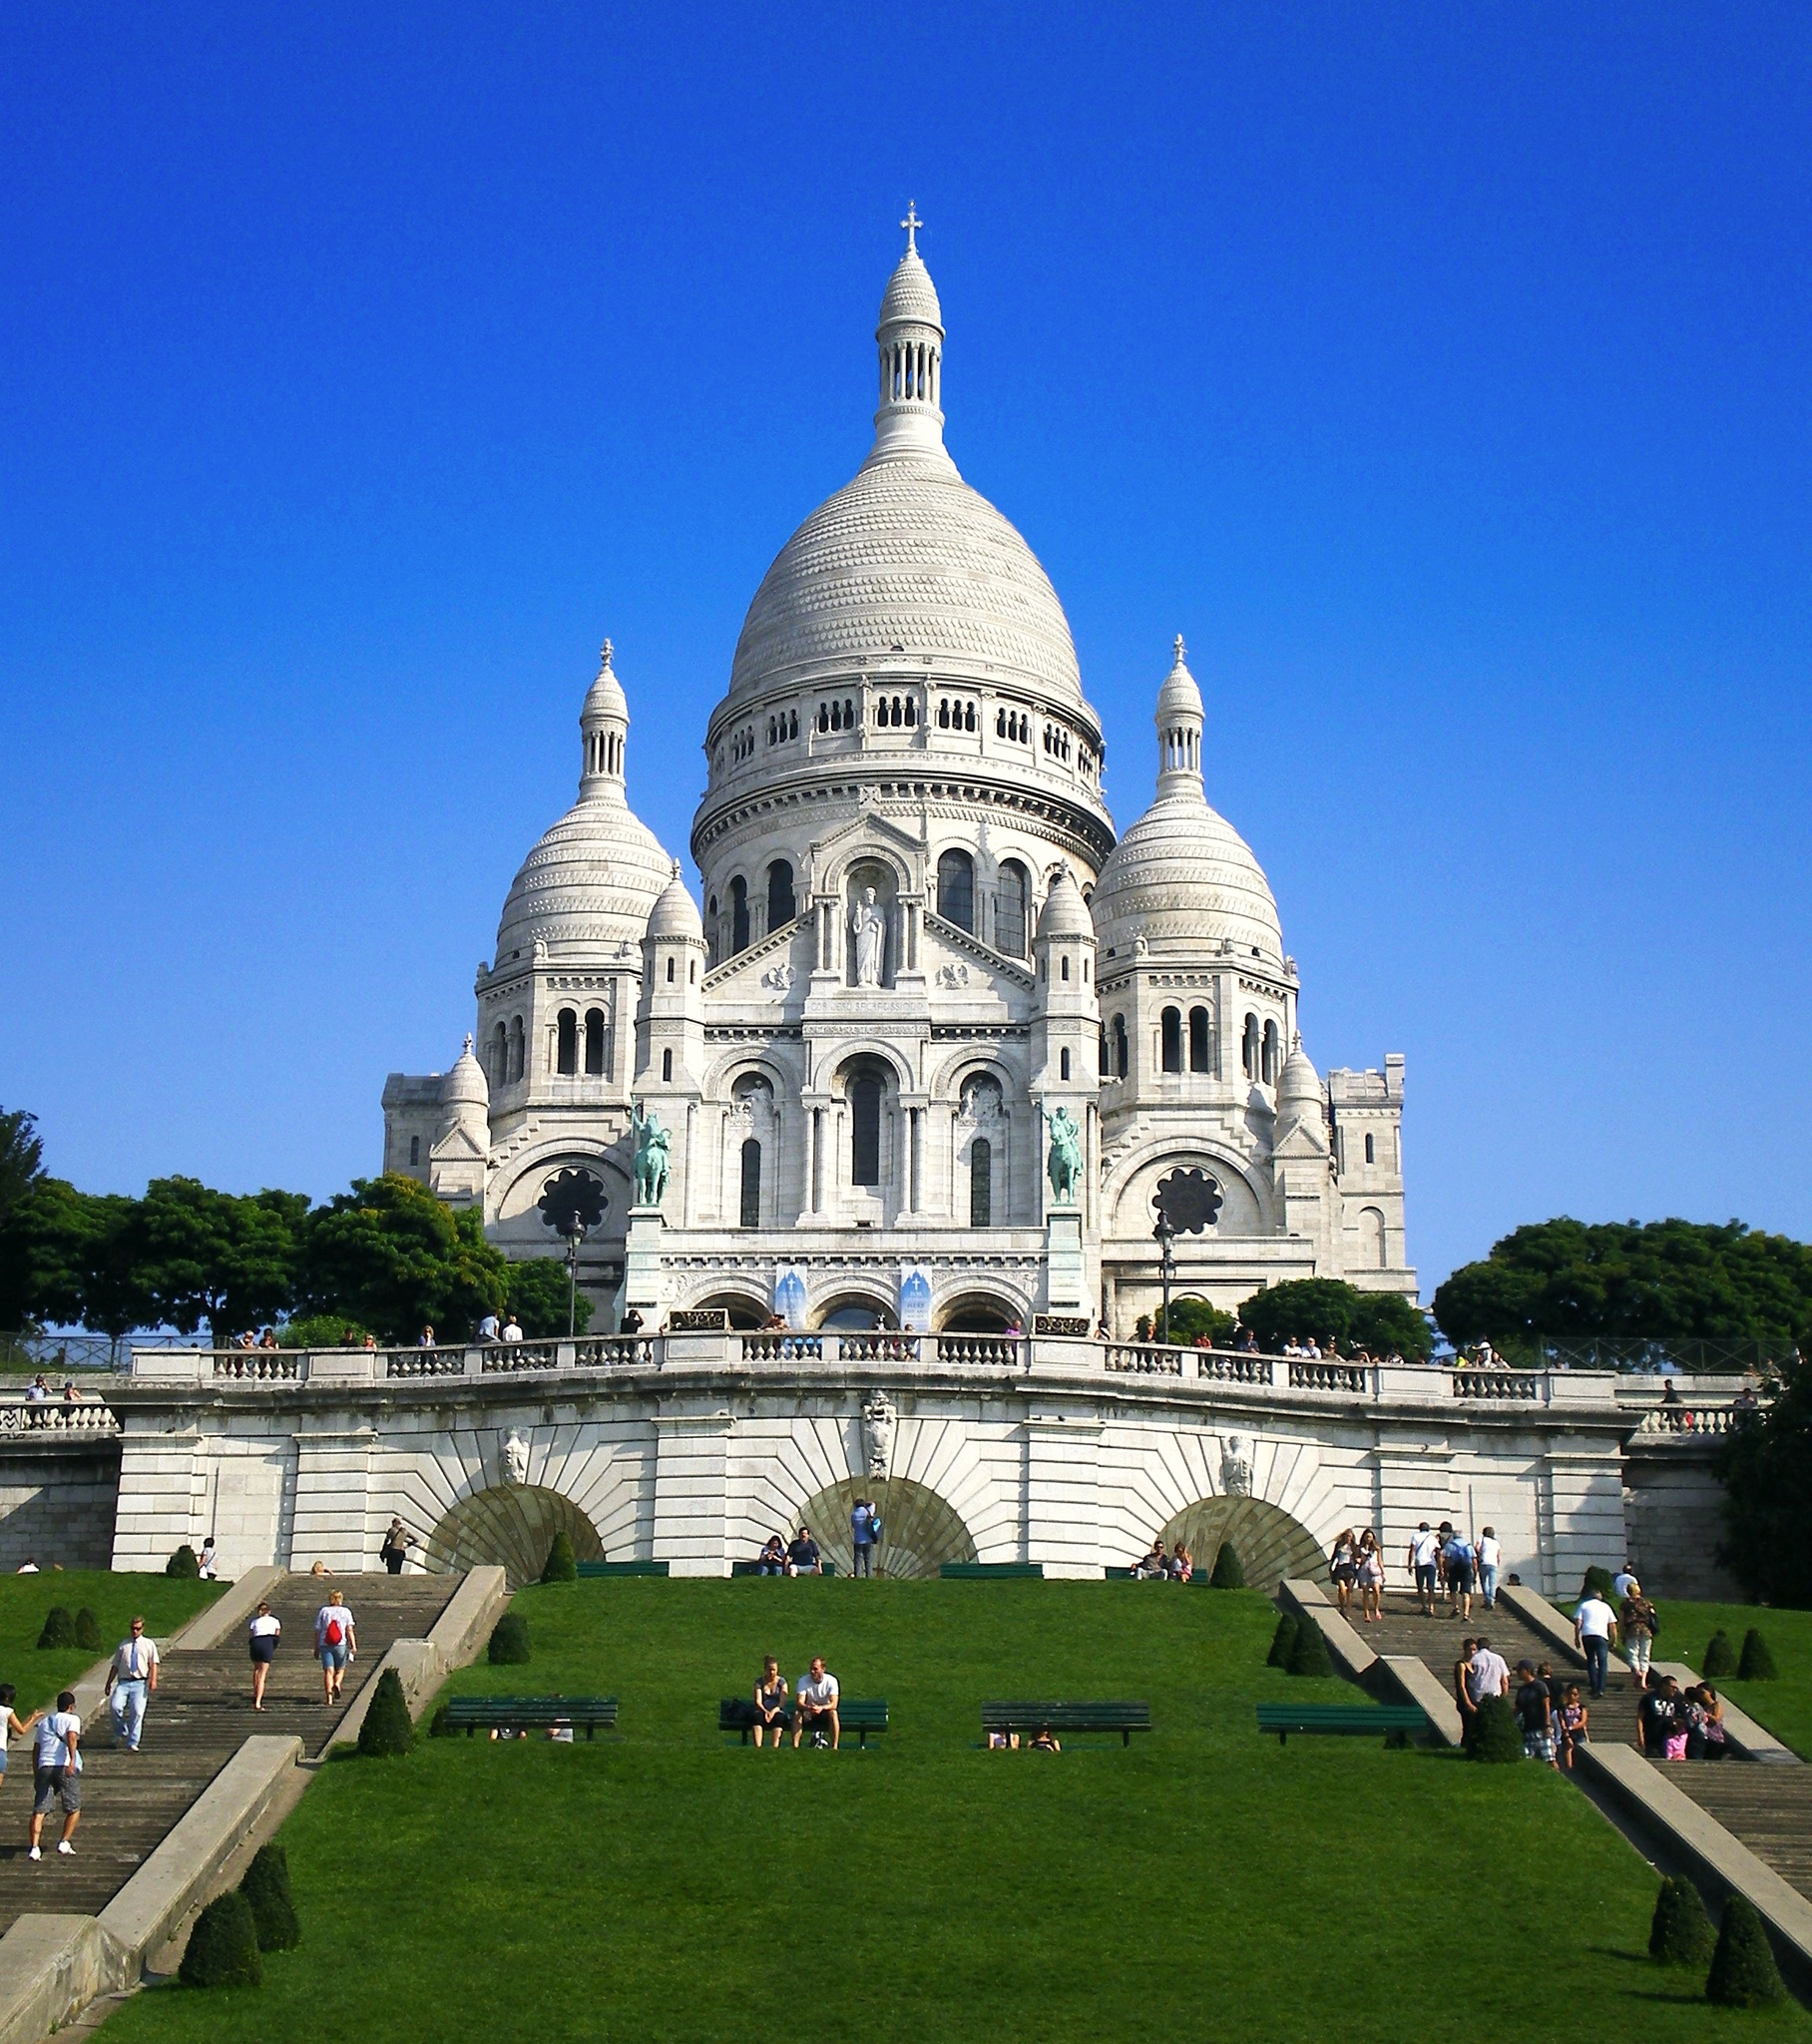What is the historical significance of the Sacr�� Coeur? The Sacr�� Coeur, completed in 1914, stands as a symbol of hope and penance for France after the Franco-Prussian War. It was built with the intent to restore faith and patriotism in the aftermath of the war and the Commune of 1871. The basilica also represents an iconic part of French national identity and serves as a beacon of peace. 